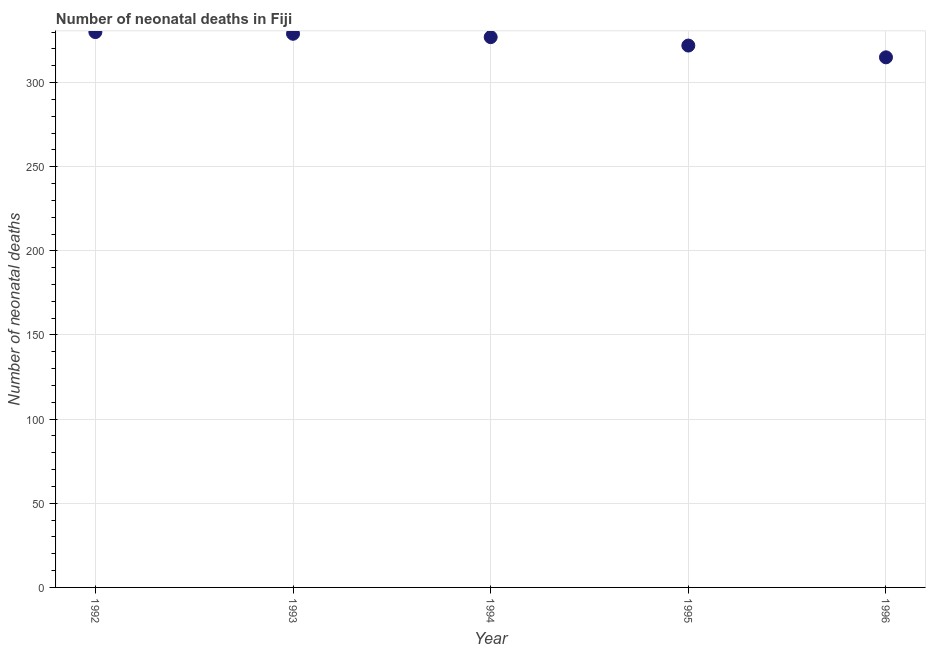What is the number of neonatal deaths in 1993?
Provide a succinct answer. 329. Across all years, what is the maximum number of neonatal deaths?
Ensure brevity in your answer.  330. Across all years, what is the minimum number of neonatal deaths?
Your answer should be very brief. 315. In which year was the number of neonatal deaths minimum?
Ensure brevity in your answer.  1996. What is the sum of the number of neonatal deaths?
Provide a succinct answer. 1623. What is the difference between the number of neonatal deaths in 1993 and 1995?
Make the answer very short. 7. What is the average number of neonatal deaths per year?
Give a very brief answer. 324.6. What is the median number of neonatal deaths?
Offer a terse response. 327. In how many years, is the number of neonatal deaths greater than 300 ?
Provide a short and direct response. 5. What is the ratio of the number of neonatal deaths in 1992 to that in 1995?
Provide a short and direct response. 1.02. What is the difference between the highest and the second highest number of neonatal deaths?
Your answer should be very brief. 1. Is the sum of the number of neonatal deaths in 1993 and 1994 greater than the maximum number of neonatal deaths across all years?
Make the answer very short. Yes. What is the difference between the highest and the lowest number of neonatal deaths?
Make the answer very short. 15. In how many years, is the number of neonatal deaths greater than the average number of neonatal deaths taken over all years?
Provide a short and direct response. 3. Does the number of neonatal deaths monotonically increase over the years?
Make the answer very short. No. How many years are there in the graph?
Ensure brevity in your answer.  5. What is the difference between two consecutive major ticks on the Y-axis?
Ensure brevity in your answer.  50. Does the graph contain any zero values?
Ensure brevity in your answer.  No. Does the graph contain grids?
Offer a very short reply. Yes. What is the title of the graph?
Provide a short and direct response. Number of neonatal deaths in Fiji. What is the label or title of the Y-axis?
Give a very brief answer. Number of neonatal deaths. What is the Number of neonatal deaths in 1992?
Your response must be concise. 330. What is the Number of neonatal deaths in 1993?
Give a very brief answer. 329. What is the Number of neonatal deaths in 1994?
Give a very brief answer. 327. What is the Number of neonatal deaths in 1995?
Offer a terse response. 322. What is the Number of neonatal deaths in 1996?
Give a very brief answer. 315. What is the difference between the Number of neonatal deaths in 1992 and 1993?
Your response must be concise. 1. What is the difference between the Number of neonatal deaths in 1992 and 1994?
Give a very brief answer. 3. What is the difference between the Number of neonatal deaths in 1993 and 1995?
Your answer should be very brief. 7. What is the difference between the Number of neonatal deaths in 1994 and 1995?
Ensure brevity in your answer.  5. What is the difference between the Number of neonatal deaths in 1995 and 1996?
Provide a succinct answer. 7. What is the ratio of the Number of neonatal deaths in 1992 to that in 1995?
Your answer should be very brief. 1.02. What is the ratio of the Number of neonatal deaths in 1992 to that in 1996?
Your response must be concise. 1.05. What is the ratio of the Number of neonatal deaths in 1993 to that in 1995?
Your response must be concise. 1.02. What is the ratio of the Number of neonatal deaths in 1993 to that in 1996?
Provide a succinct answer. 1.04. What is the ratio of the Number of neonatal deaths in 1994 to that in 1995?
Your answer should be very brief. 1.02. What is the ratio of the Number of neonatal deaths in 1994 to that in 1996?
Provide a succinct answer. 1.04. 